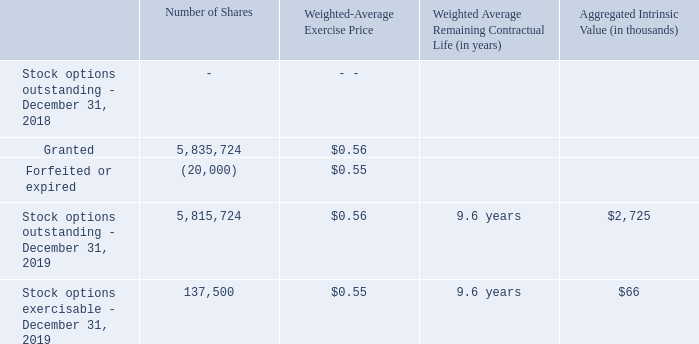The following table summarizes the activity related to stock options during the year ended December 31, 2019
As of December 31, 2019, the Company had $1,641 of unrecognized stock-based compensation expense related to the stock options. This cost is expected to be recognized over a weighted-average period of 2.5 years.
(Dollars in thousands, except per share amounts)
What is the value of unrecognized stock-based compensation expense related to the stock options at December 31, 2019?
Answer scale should be: thousand. $1,641. What are the respective stock options outstanding and exercisable at December 31, 2019? 5,815,724, 137,500. What are the weighted-average exercise price of the stock options outstanding and exercisable at December 31, 2019? $0.56, $0.55. What is the value of the stock options granted as a percentage of the total stock options outstanding as at December 31, 2019?
Answer scale should be: percent. 5,835,724/5,815,724 
Answer: 100.34. What is the average number of stocks outstanding as at December 31, 2018 and 2019? (5,815,724 + 0)/2  
Answer: 2907862. What is the total number of stocks outstanding as at December 31, 2018 and 2019? 5,815,724 + 0 
Answer: 5815724. 